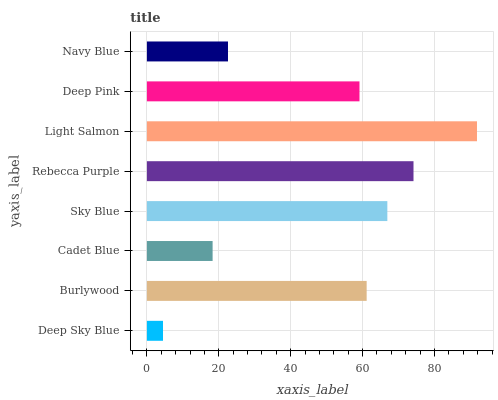Is Deep Sky Blue the minimum?
Answer yes or no. Yes. Is Light Salmon the maximum?
Answer yes or no. Yes. Is Burlywood the minimum?
Answer yes or no. No. Is Burlywood the maximum?
Answer yes or no. No. Is Burlywood greater than Deep Sky Blue?
Answer yes or no. Yes. Is Deep Sky Blue less than Burlywood?
Answer yes or no. Yes. Is Deep Sky Blue greater than Burlywood?
Answer yes or no. No. Is Burlywood less than Deep Sky Blue?
Answer yes or no. No. Is Burlywood the high median?
Answer yes or no. Yes. Is Deep Pink the low median?
Answer yes or no. Yes. Is Light Salmon the high median?
Answer yes or no. No. Is Sky Blue the low median?
Answer yes or no. No. 